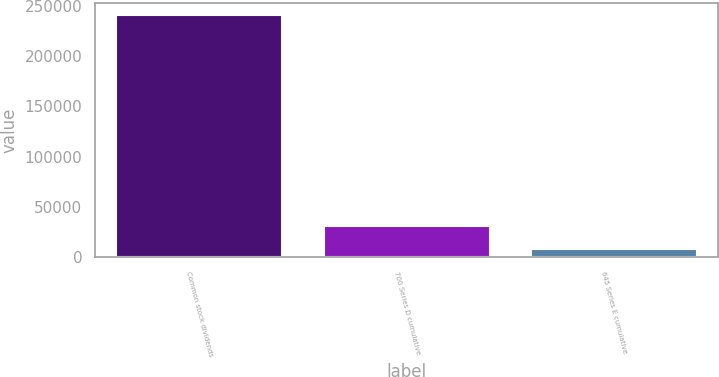<chart> <loc_0><loc_0><loc_500><loc_500><bar_chart><fcel>Common stock dividends<fcel>700 Series D cumulative<fcel>645 Series E cumulative<nl><fcel>240347<fcel>31581.2<fcel>8385<nl></chart> 